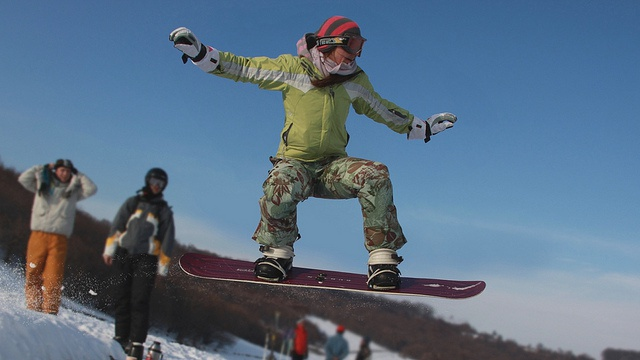Describe the objects in this image and their specific colors. I can see people in gray, black, olive, and darkgreen tones, people in gray, black, and darkgray tones, people in gray, brown, maroon, and darkgray tones, snowboard in gray, black, purple, and darkgray tones, and people in gray, maroon, black, and brown tones in this image. 